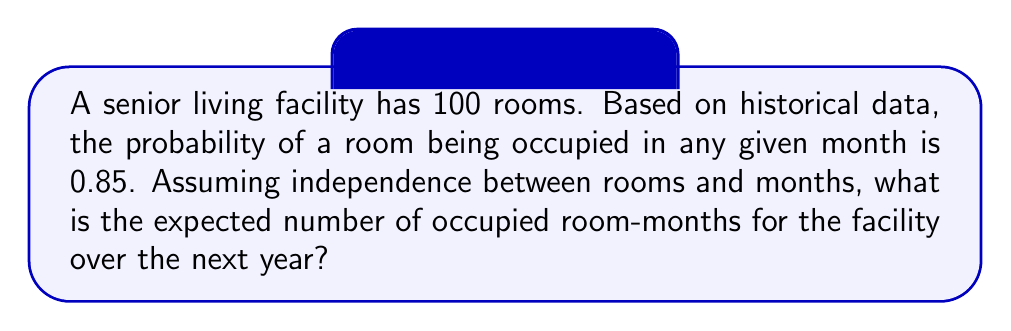What is the answer to this math problem? Let's approach this step-by-step:

1) First, we need to understand what "expected value" means. The expected value is the average outcome of an experiment if it is repeated many times.

2) In this case, each room for each month can be considered an independent "experiment" with two possible outcomes: occupied (probability 0.85) or unoccupied (probability 0.15).

3) For a single room in a single month, the expected occupancy can be calculated as:

   $E(\text{single room-month}) = 1 \cdot 0.85 + 0 \cdot 0.15 = 0.85$

4) Now, we need to consider all rooms for an entire year. We have:
   - 100 rooms
   - 12 months

5) The total number of room-months is:

   $\text{Total room-months} = 100 \text{ rooms} \cdot 12 \text{ months} = 1200 \text{ room-months}$

6) Since each room-month is independent and has the same probability of being occupied, we can multiply the expected value for a single room-month by the total number of room-months:

   $E(\text{total occupied room-months}) = 0.85 \cdot 1200 = 1020$

Therefore, the expected number of occupied room-months over the next year is 1020.
Answer: 1020 room-months 